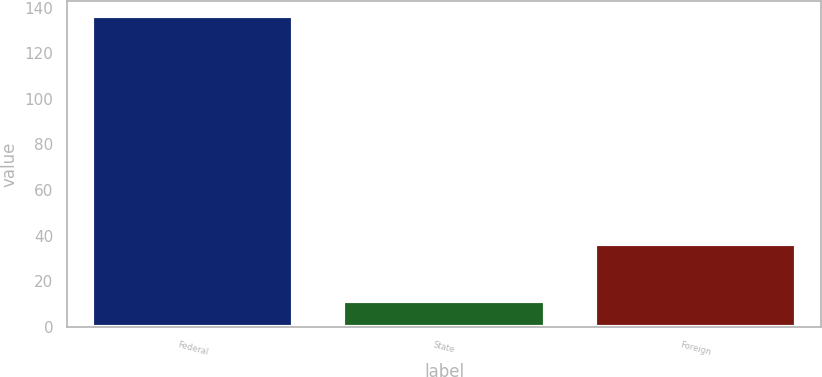<chart> <loc_0><loc_0><loc_500><loc_500><bar_chart><fcel>Federal<fcel>State<fcel>Foreign<nl><fcel>136.2<fcel>11.4<fcel>36.6<nl></chart> 